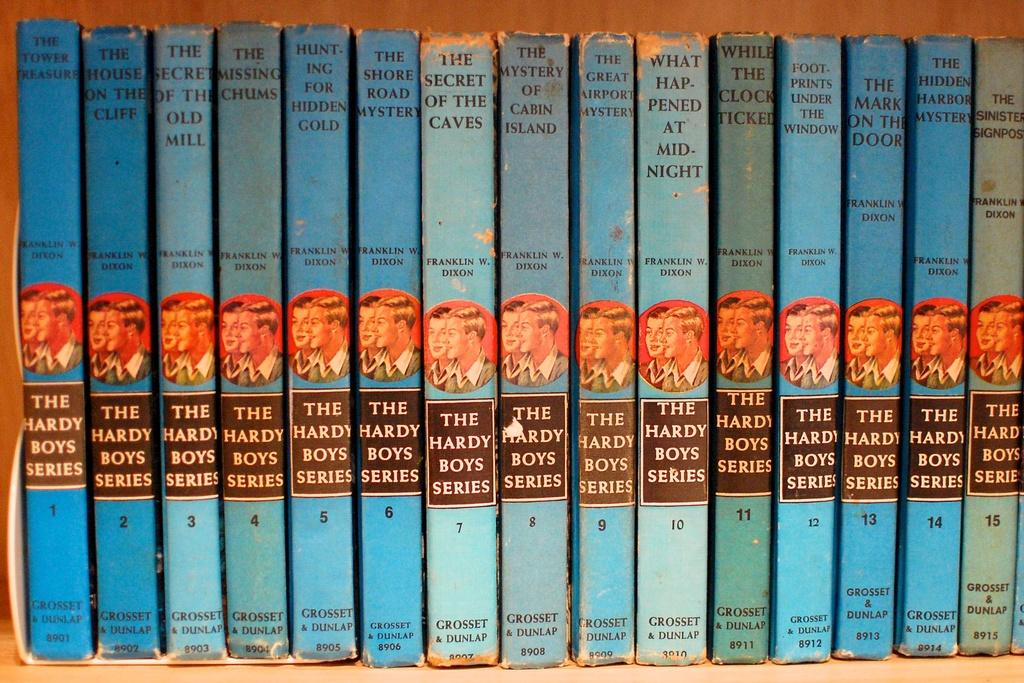Provide a one-sentence caption for the provided image. A bookshelf filled with The Hardy Boys series books. 